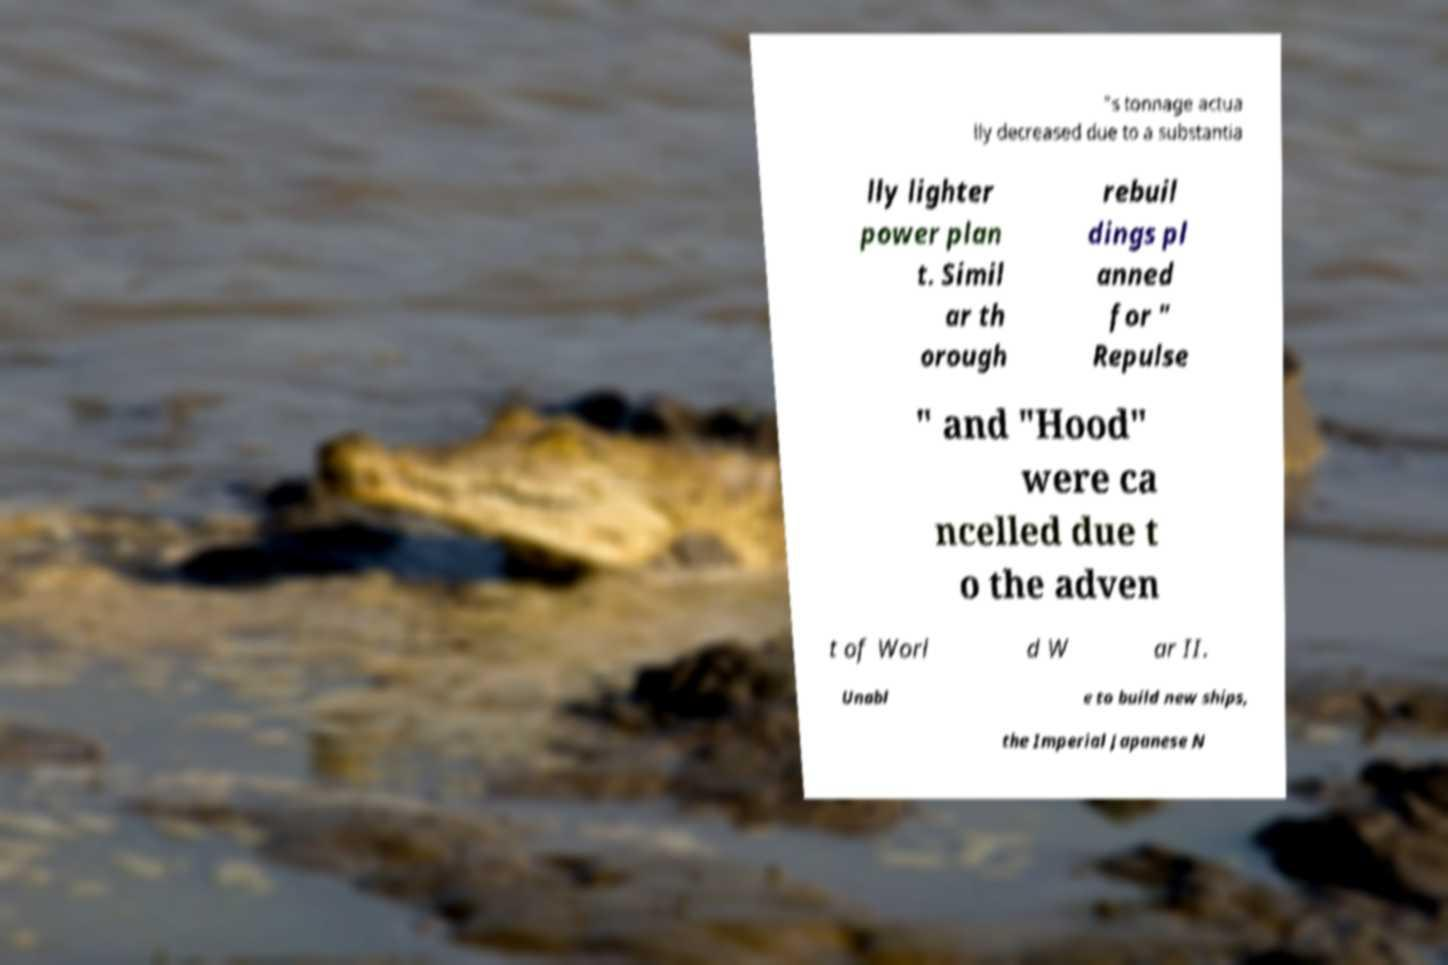Can you accurately transcribe the text from the provided image for me? "s tonnage actua lly decreased due to a substantia lly lighter power plan t. Simil ar th orough rebuil dings pl anned for " Repulse " and "Hood" were ca ncelled due t o the adven t of Worl d W ar II. Unabl e to build new ships, the Imperial Japanese N 